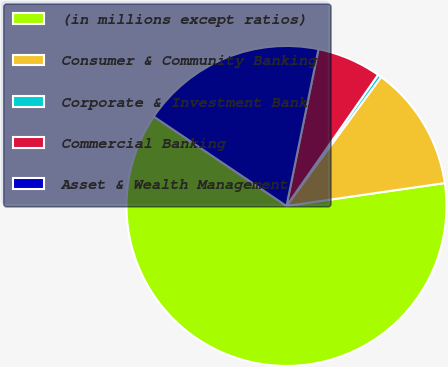Convert chart to OTSL. <chart><loc_0><loc_0><loc_500><loc_500><pie_chart><fcel>(in millions except ratios)<fcel>Consumer & Community Banking<fcel>Corporate & Investment Bank<fcel>Commercial Banking<fcel>Asset & Wealth Management<nl><fcel>61.72%<fcel>12.64%<fcel>0.37%<fcel>6.5%<fcel>18.77%<nl></chart> 